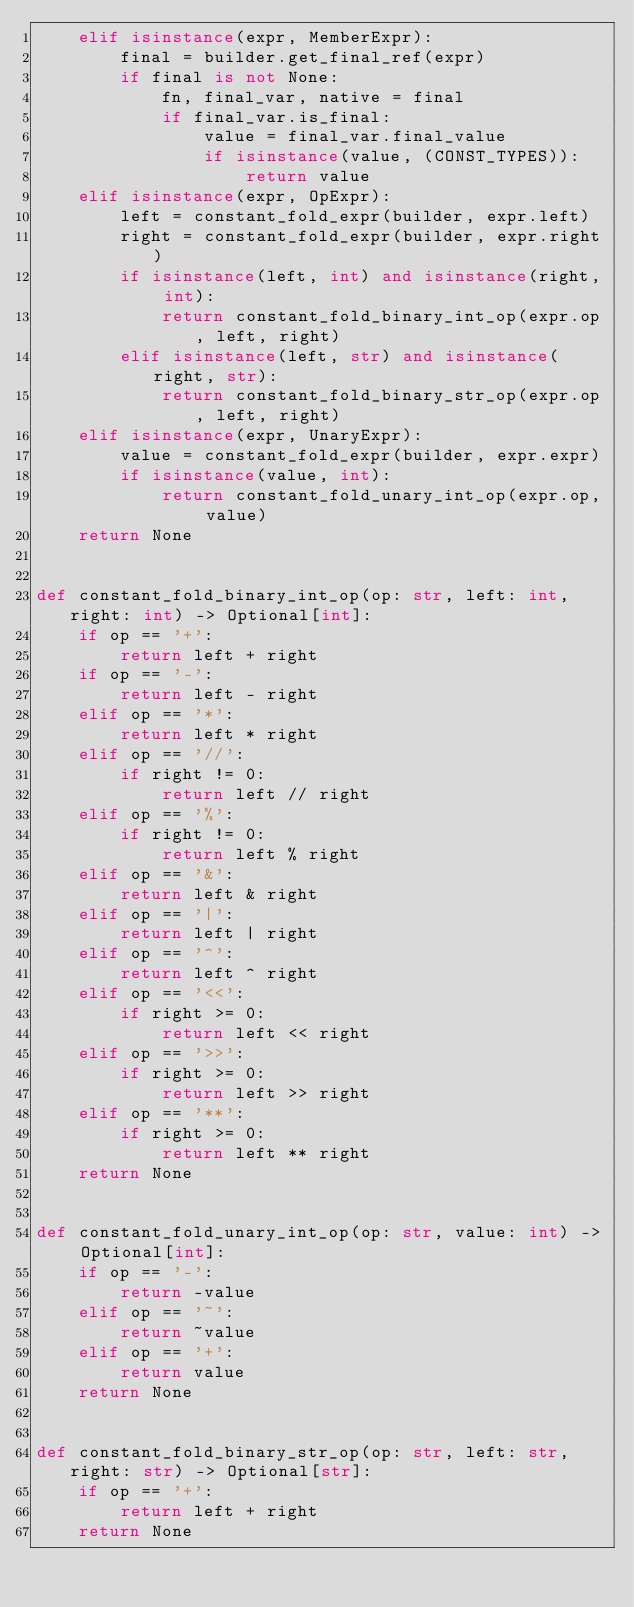<code> <loc_0><loc_0><loc_500><loc_500><_Python_>    elif isinstance(expr, MemberExpr):
        final = builder.get_final_ref(expr)
        if final is not None:
            fn, final_var, native = final
            if final_var.is_final:
                value = final_var.final_value
                if isinstance(value, (CONST_TYPES)):
                    return value
    elif isinstance(expr, OpExpr):
        left = constant_fold_expr(builder, expr.left)
        right = constant_fold_expr(builder, expr.right)
        if isinstance(left, int) and isinstance(right, int):
            return constant_fold_binary_int_op(expr.op, left, right)
        elif isinstance(left, str) and isinstance(right, str):
            return constant_fold_binary_str_op(expr.op, left, right)
    elif isinstance(expr, UnaryExpr):
        value = constant_fold_expr(builder, expr.expr)
        if isinstance(value, int):
            return constant_fold_unary_int_op(expr.op, value)
    return None


def constant_fold_binary_int_op(op: str, left: int, right: int) -> Optional[int]:
    if op == '+':
        return left + right
    if op == '-':
        return left - right
    elif op == '*':
        return left * right
    elif op == '//':
        if right != 0:
            return left // right
    elif op == '%':
        if right != 0:
            return left % right
    elif op == '&':
        return left & right
    elif op == '|':
        return left | right
    elif op == '^':
        return left ^ right
    elif op == '<<':
        if right >= 0:
            return left << right
    elif op == '>>':
        if right >= 0:
            return left >> right
    elif op == '**':
        if right >= 0:
            return left ** right
    return None


def constant_fold_unary_int_op(op: str, value: int) -> Optional[int]:
    if op == '-':
        return -value
    elif op == '~':
        return ~value
    elif op == '+':
        return value
    return None


def constant_fold_binary_str_op(op: str, left: str, right: str) -> Optional[str]:
    if op == '+':
        return left + right
    return None
</code> 